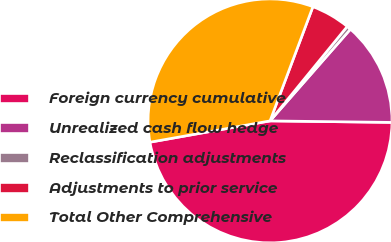Convert chart to OTSL. <chart><loc_0><loc_0><loc_500><loc_500><pie_chart><fcel>Foreign currency cumulative<fcel>Unrealized cash flow hedge<fcel>Reclassification adjustments<fcel>Adjustments to prior service<fcel>Total Other Comprehensive<nl><fcel>47.01%<fcel>13.74%<fcel>0.55%<fcel>5.19%<fcel>33.51%<nl></chart> 